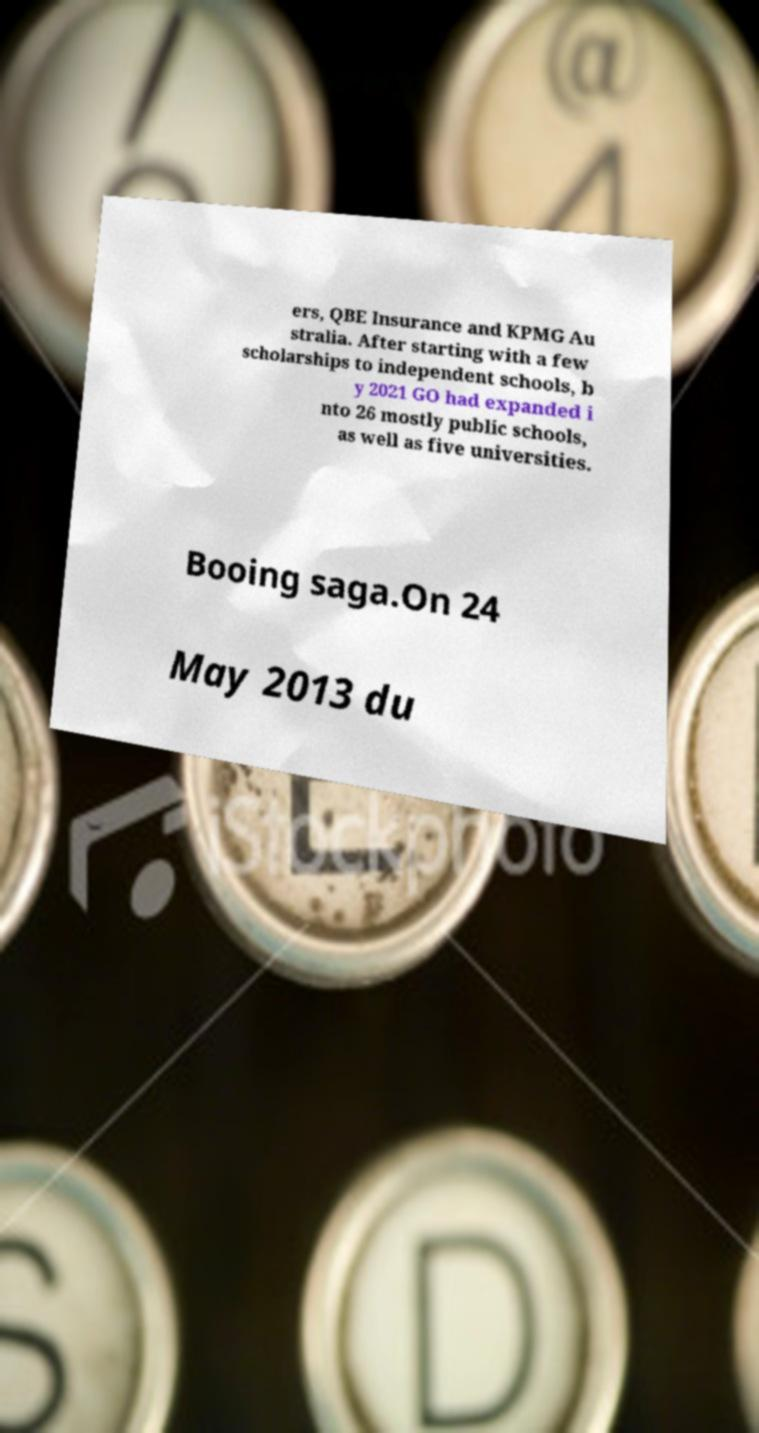There's text embedded in this image that I need extracted. Can you transcribe it verbatim? ers, QBE Insurance and KPMG Au stralia. After starting with a few scholarships to independent schools, b y 2021 GO had expanded i nto 26 mostly public schools, as well as five universities. Booing saga.On 24 May 2013 du 